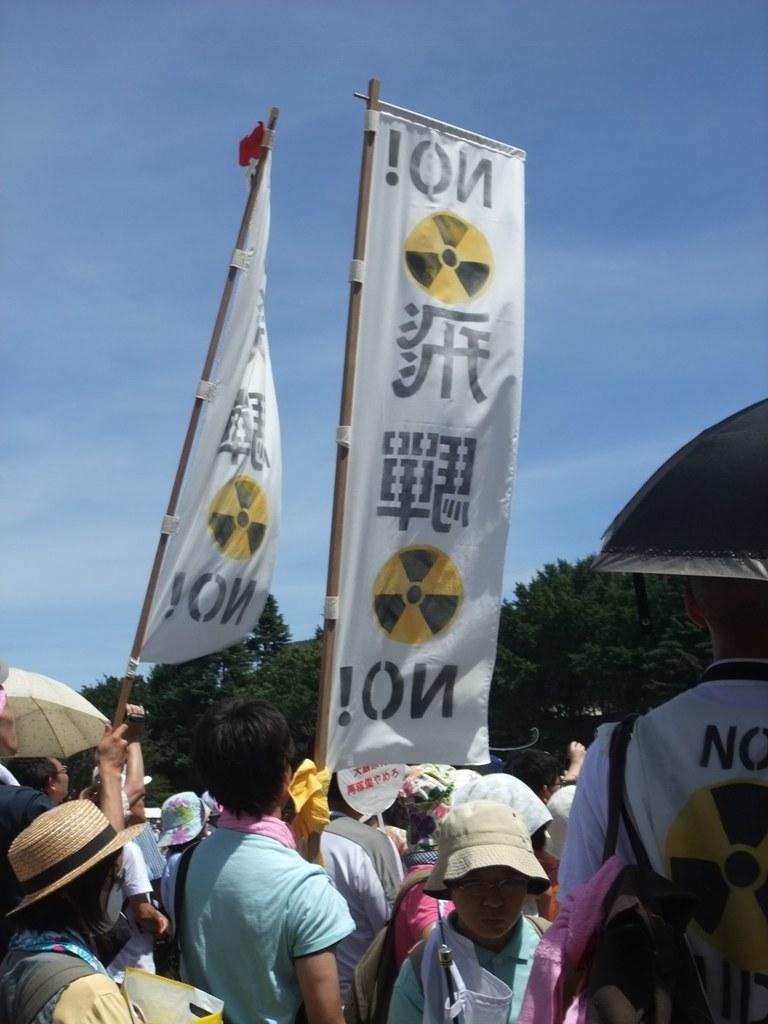How would you summarize this image in a sentence or two? Here we can see few people, among them few wore hat on their head and two persons are holding hoarding sticks and we can also see two umbrellas. In the background there are trees and clouds in the sky. 